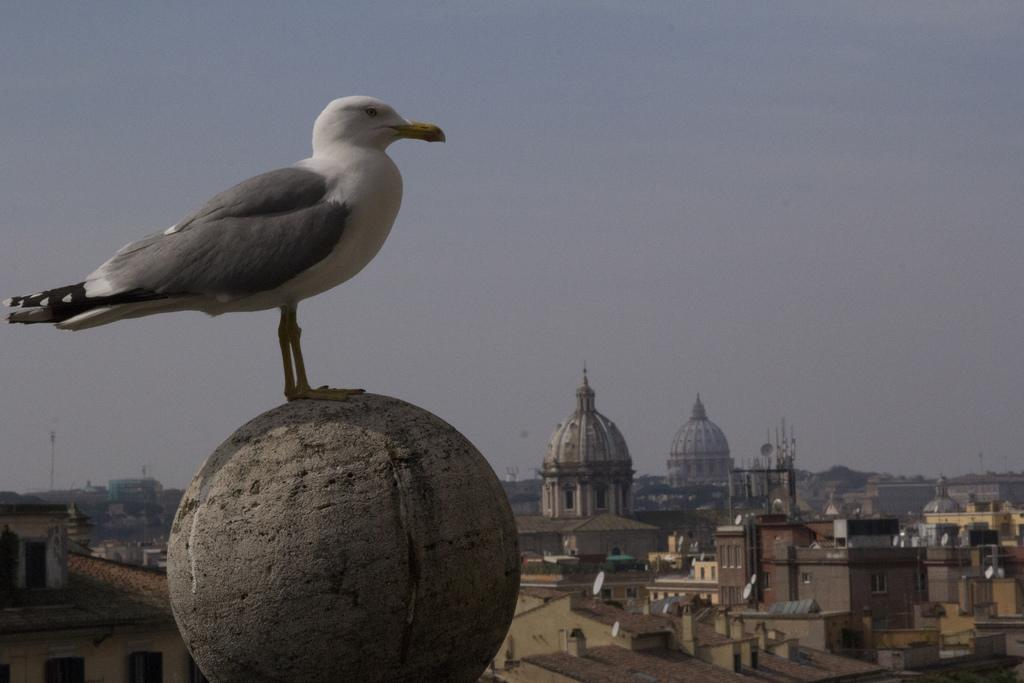What type of animal can be seen in the image? There is a bird in the image. What is the bird standing on? The bird is standing on a circular object. What can be seen in the background of the image? There are buildings, poles, satellite dishes, and the sky visible in the background of the image. What type of string is the bird playing with in the image? There is no string present in the image; the bird is simply standing on a circular object. 